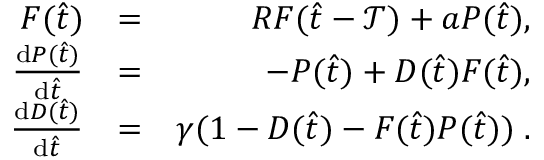<formula> <loc_0><loc_0><loc_500><loc_500>\begin{array} { r l r } { F ( \hat { t } ) } & { = } & { R F ( \hat { t } - \mathcal { T } ) + a P ( \hat { t } ) , } \\ { \frac { d P ( \hat { t } ) } { d \hat { t } } } & { = } & { - P ( \hat { t } ) + D ( \hat { t } ) F ( \hat { t } ) , } \\ { \frac { d D ( \hat { t } ) } { d \hat { t } } } & { = } & { \gamma ( 1 - D ( \hat { t } ) - F ( \hat { t } ) P ( \hat { t } ) ) \, . } \end{array}</formula> 